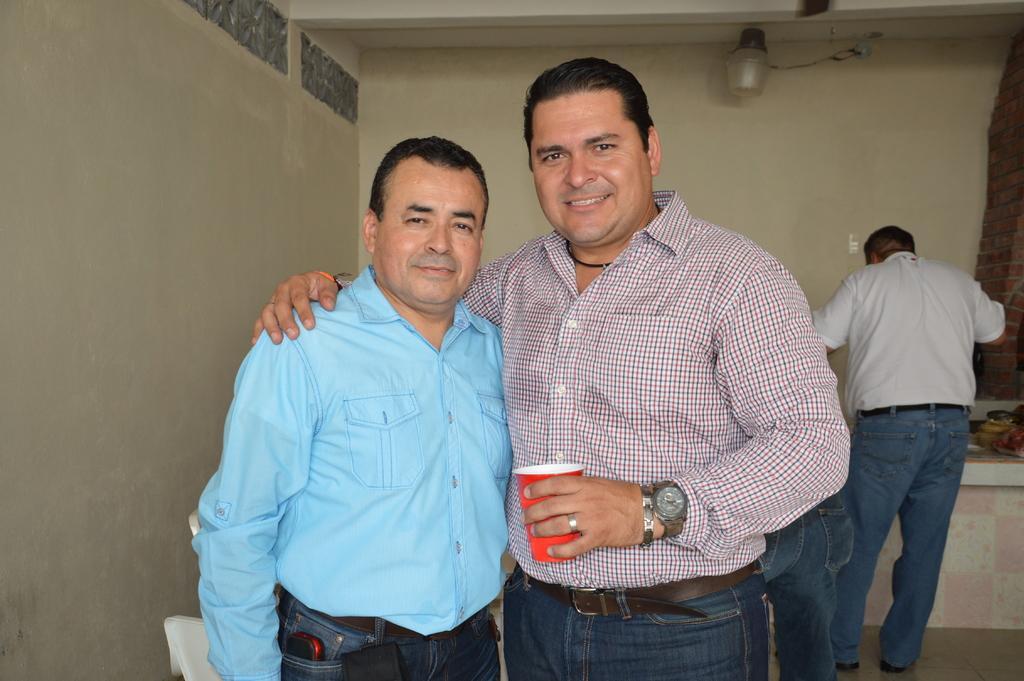Describe this image in one or two sentences. There are two men standing. Person on the right is holding a cup and wearing a watch. In the back there's a wall with light. And another person is standing on the right side. Also there is a table. On that there are some items. And a brick wall is on the right side. 